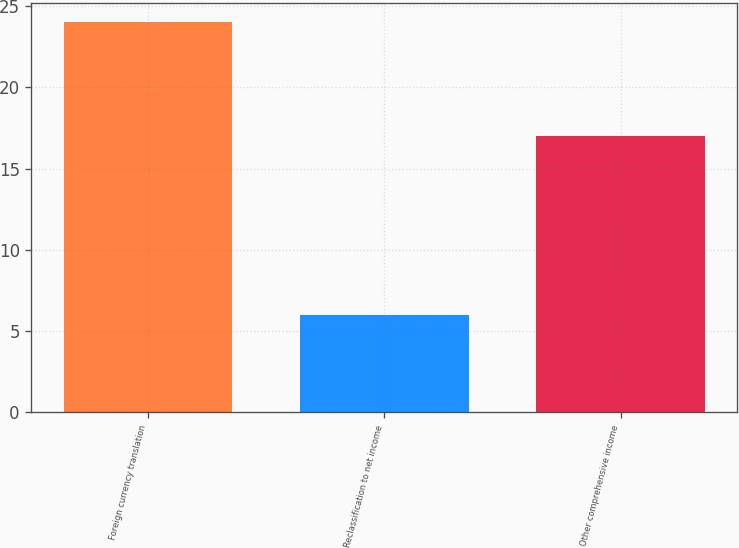Convert chart to OTSL. <chart><loc_0><loc_0><loc_500><loc_500><bar_chart><fcel>Foreign currency translation<fcel>Reclassification to net income<fcel>Other comprehensive income<nl><fcel>24<fcel>6<fcel>17<nl></chart> 